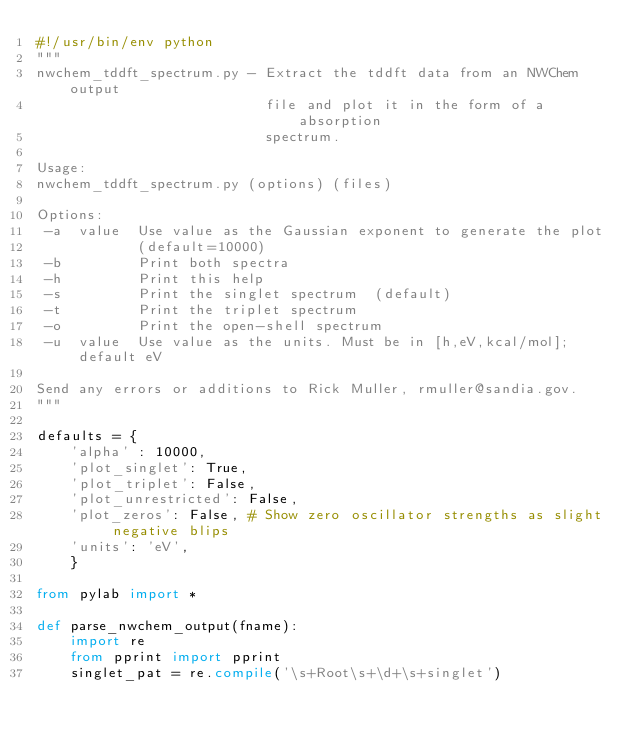<code> <loc_0><loc_0><loc_500><loc_500><_Python_>#!/usr/bin/env python
"""
nwchem_tddft_spectrum.py - Extract the tddft data from an NWChem output
                           file and plot it in the form of a absorption
                           spectrum.

Usage:
nwchem_tddft_spectrum.py (options) (files)

Options:
 -a  value  Use value as the Gaussian exponent to generate the plot
            (default=10000)
 -b         Print both spectra
 -h         Print this help
 -s         Print the singlet spectrum  (default)
 -t         Print the triplet spectrum
 -o         Print the open-shell spectrum
 -u  value  Use value as the units. Must be in [h,eV,kcal/mol]; default eV

Send any errors or additions to Rick Muller, rmuller@sandia.gov.
"""

defaults = {
    'alpha' : 10000,
    'plot_singlet': True,
    'plot_triplet': False,
    'plot_unrestricted': False,
    'plot_zeros': False, # Show zero oscillator strengths as slight negative blips
    'units': 'eV',
    }

from pylab import *

def parse_nwchem_output(fname):
    import re
    from pprint import pprint
    singlet_pat = re.compile('\s+Root\s+\d+\s+singlet')</code> 